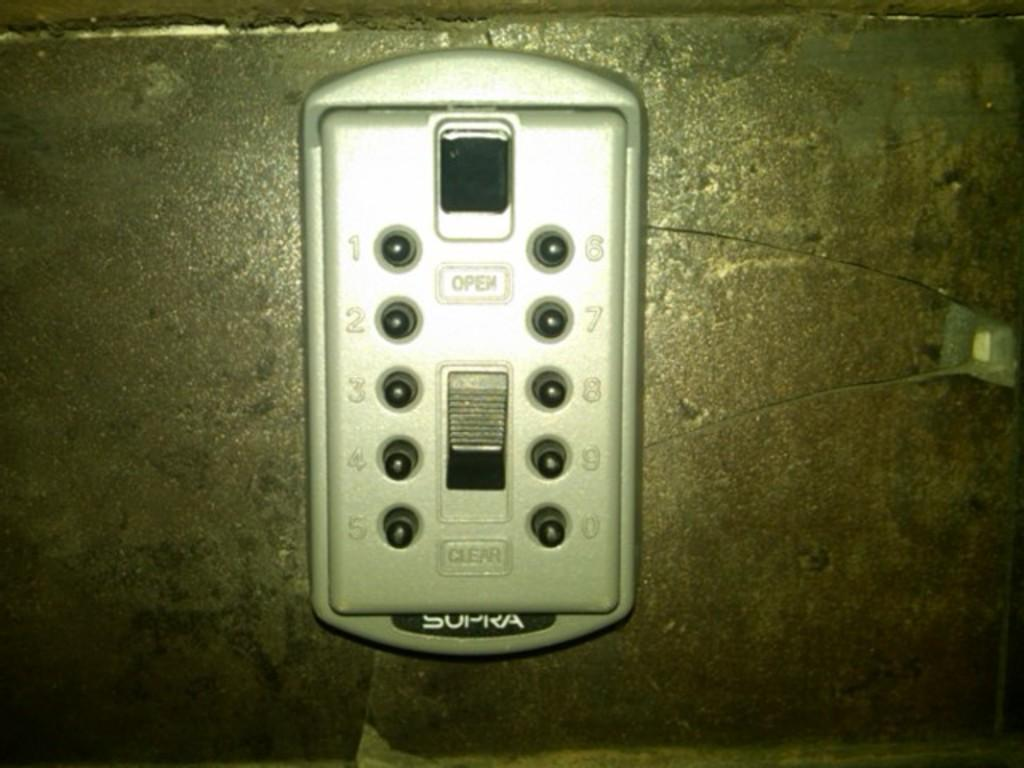<image>
Present a compact description of the photo's key features. A Supra brand key safe has indicators for "open" and "clear" on it. 